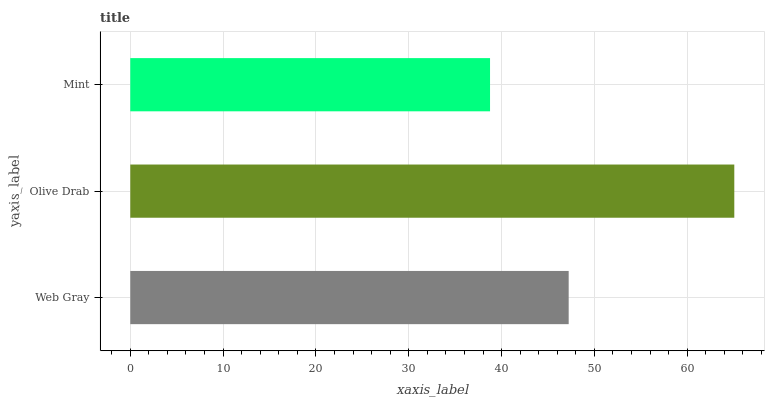Is Mint the minimum?
Answer yes or no. Yes. Is Olive Drab the maximum?
Answer yes or no. Yes. Is Olive Drab the minimum?
Answer yes or no. No. Is Mint the maximum?
Answer yes or no. No. Is Olive Drab greater than Mint?
Answer yes or no. Yes. Is Mint less than Olive Drab?
Answer yes or no. Yes. Is Mint greater than Olive Drab?
Answer yes or no. No. Is Olive Drab less than Mint?
Answer yes or no. No. Is Web Gray the high median?
Answer yes or no. Yes. Is Web Gray the low median?
Answer yes or no. Yes. Is Olive Drab the high median?
Answer yes or no. No. Is Mint the low median?
Answer yes or no. No. 